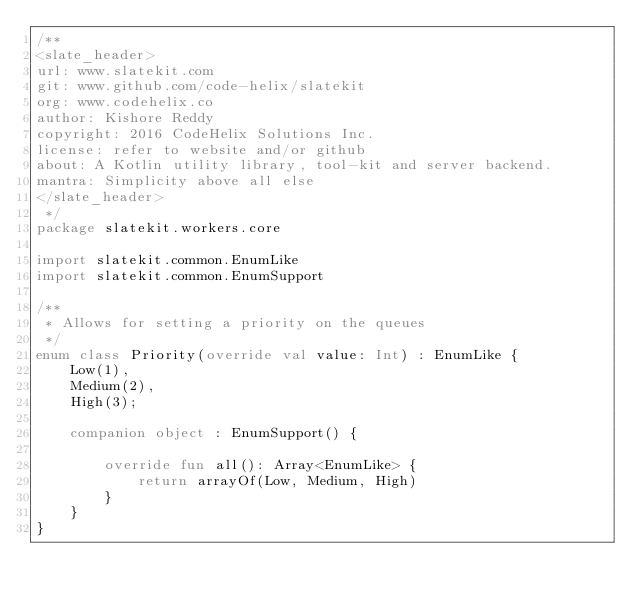Convert code to text. <code><loc_0><loc_0><loc_500><loc_500><_Kotlin_>/**
<slate_header>
url: www.slatekit.com
git: www.github.com/code-helix/slatekit
org: www.codehelix.co
author: Kishore Reddy
copyright: 2016 CodeHelix Solutions Inc.
license: refer to website and/or github
about: A Kotlin utility library, tool-kit and server backend.
mantra: Simplicity above all else
</slate_header>
 */
package slatekit.workers.core

import slatekit.common.EnumLike
import slatekit.common.EnumSupport

/**
 * Allows for setting a priority on the queues
 */
enum class Priority(override val value: Int) : EnumLike {
    Low(1),
    Medium(2),
    High(3);

    companion object : EnumSupport() {

        override fun all(): Array<EnumLike> {
            return arrayOf(Low, Medium, High)
        }
    }
}
</code> 